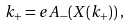Convert formula to latex. <formula><loc_0><loc_0><loc_500><loc_500>k _ { + } = e A _ { - } ( X ( k _ { + } ) ) \, ,</formula> 